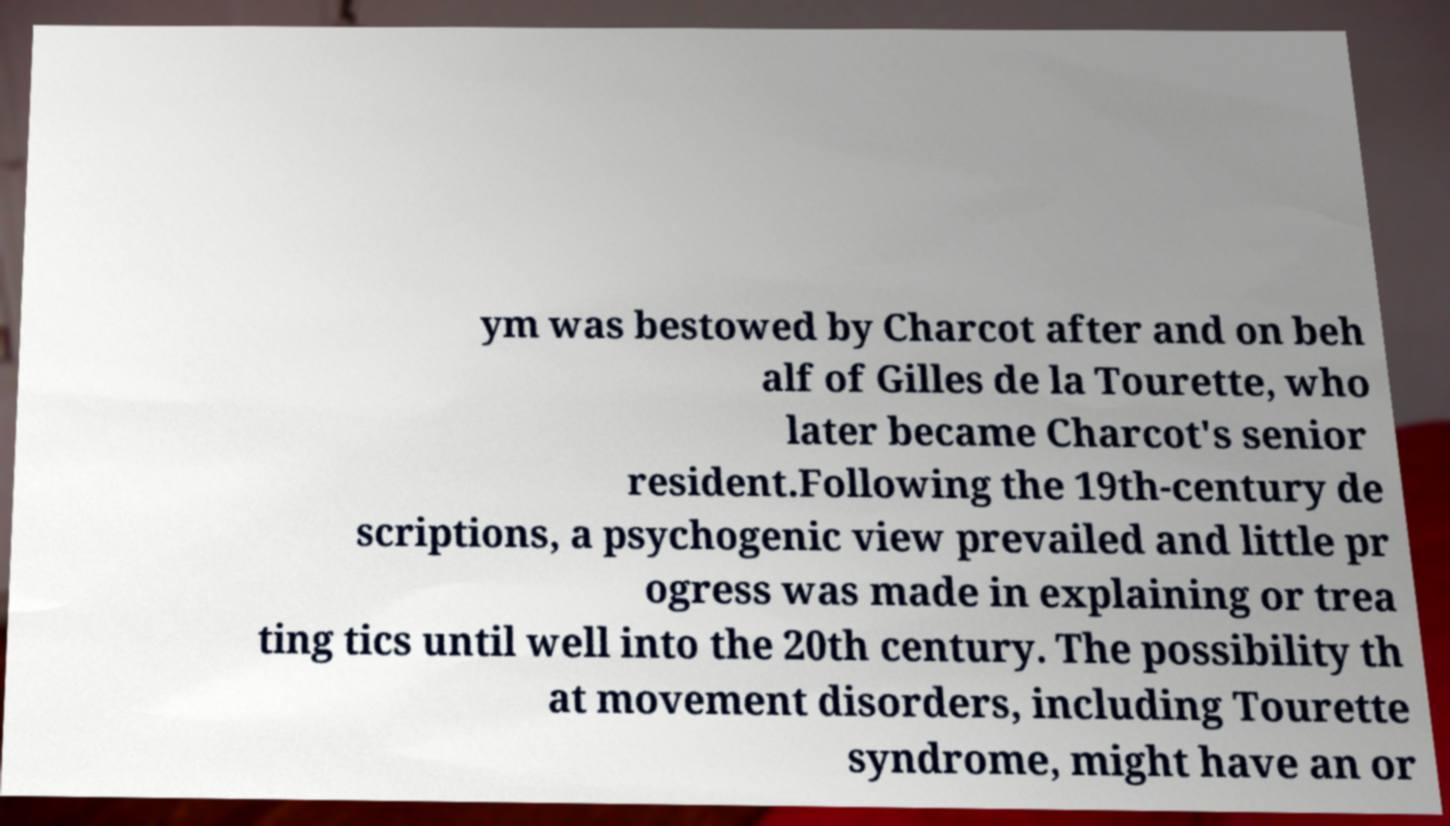Could you assist in decoding the text presented in this image and type it out clearly? ym was bestowed by Charcot after and on beh alf of Gilles de la Tourette, who later became Charcot's senior resident.Following the 19th-century de scriptions, a psychogenic view prevailed and little pr ogress was made in explaining or trea ting tics until well into the 20th century. The possibility th at movement disorders, including Tourette syndrome, might have an or 